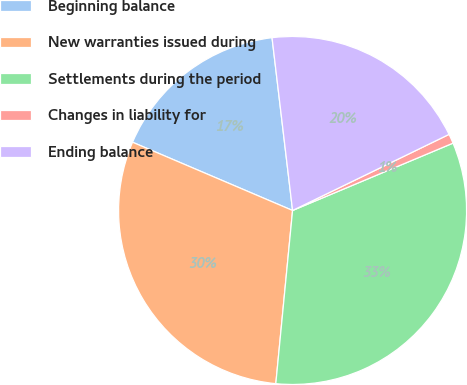Convert chart. <chart><loc_0><loc_0><loc_500><loc_500><pie_chart><fcel>Beginning balance<fcel>New warranties issued during<fcel>Settlements during the period<fcel>Changes in liability for<fcel>Ending balance<nl><fcel>16.7%<fcel>29.88%<fcel>32.86%<fcel>0.88%<fcel>19.68%<nl></chart> 